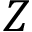<formula> <loc_0><loc_0><loc_500><loc_500>Z</formula> 